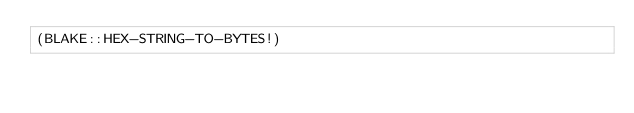Convert code to text. <code><loc_0><loc_0><loc_500><loc_500><_Lisp_>(BLAKE::HEX-STRING-TO-BYTES!)
</code> 